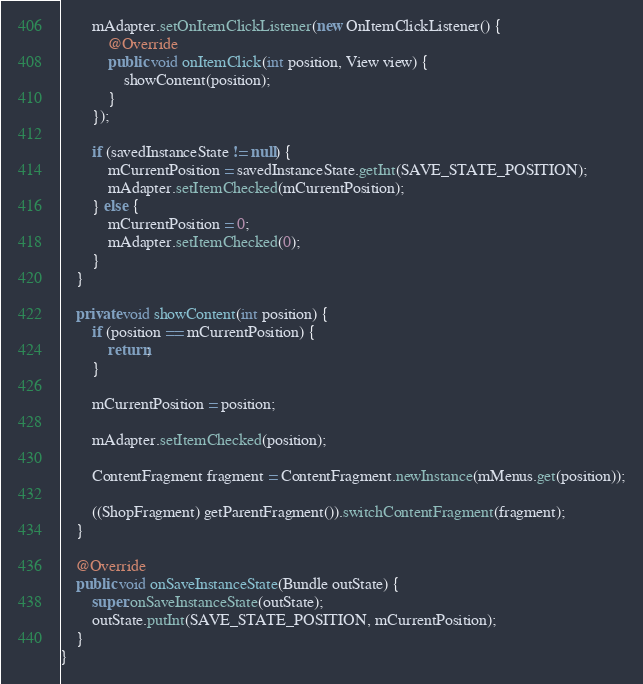Convert code to text. <code><loc_0><loc_0><loc_500><loc_500><_Java_>        mAdapter.setOnItemClickListener(new OnItemClickListener() {
            @Override
            public void onItemClick(int position, View view) {
                showContent(position);
            }
        });

        if (savedInstanceState != null) {
            mCurrentPosition = savedInstanceState.getInt(SAVE_STATE_POSITION);
            mAdapter.setItemChecked(mCurrentPosition);
        } else {
            mCurrentPosition = 0;
            mAdapter.setItemChecked(0);
        }
    }

    private void showContent(int position) {
        if (position == mCurrentPosition) {
            return;
        }

        mCurrentPosition = position;

        mAdapter.setItemChecked(position);

        ContentFragment fragment = ContentFragment.newInstance(mMenus.get(position));

        ((ShopFragment) getParentFragment()).switchContentFragment(fragment);
    }

    @Override
    public void onSaveInstanceState(Bundle outState) {
        super.onSaveInstanceState(outState);
        outState.putInt(SAVE_STATE_POSITION, mCurrentPosition);
    }
}
</code> 